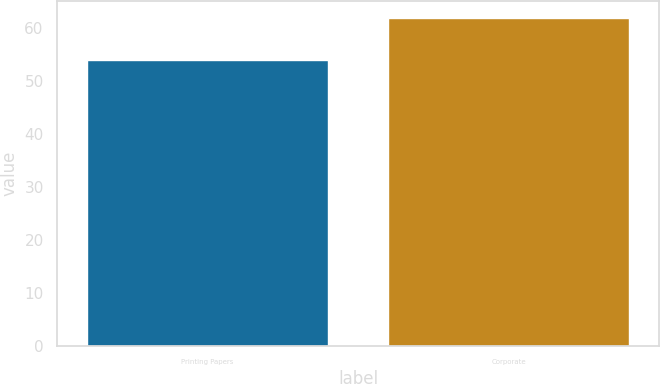Convert chart to OTSL. <chart><loc_0><loc_0><loc_500><loc_500><bar_chart><fcel>Printing Papers<fcel>Corporate<nl><fcel>54<fcel>62<nl></chart> 